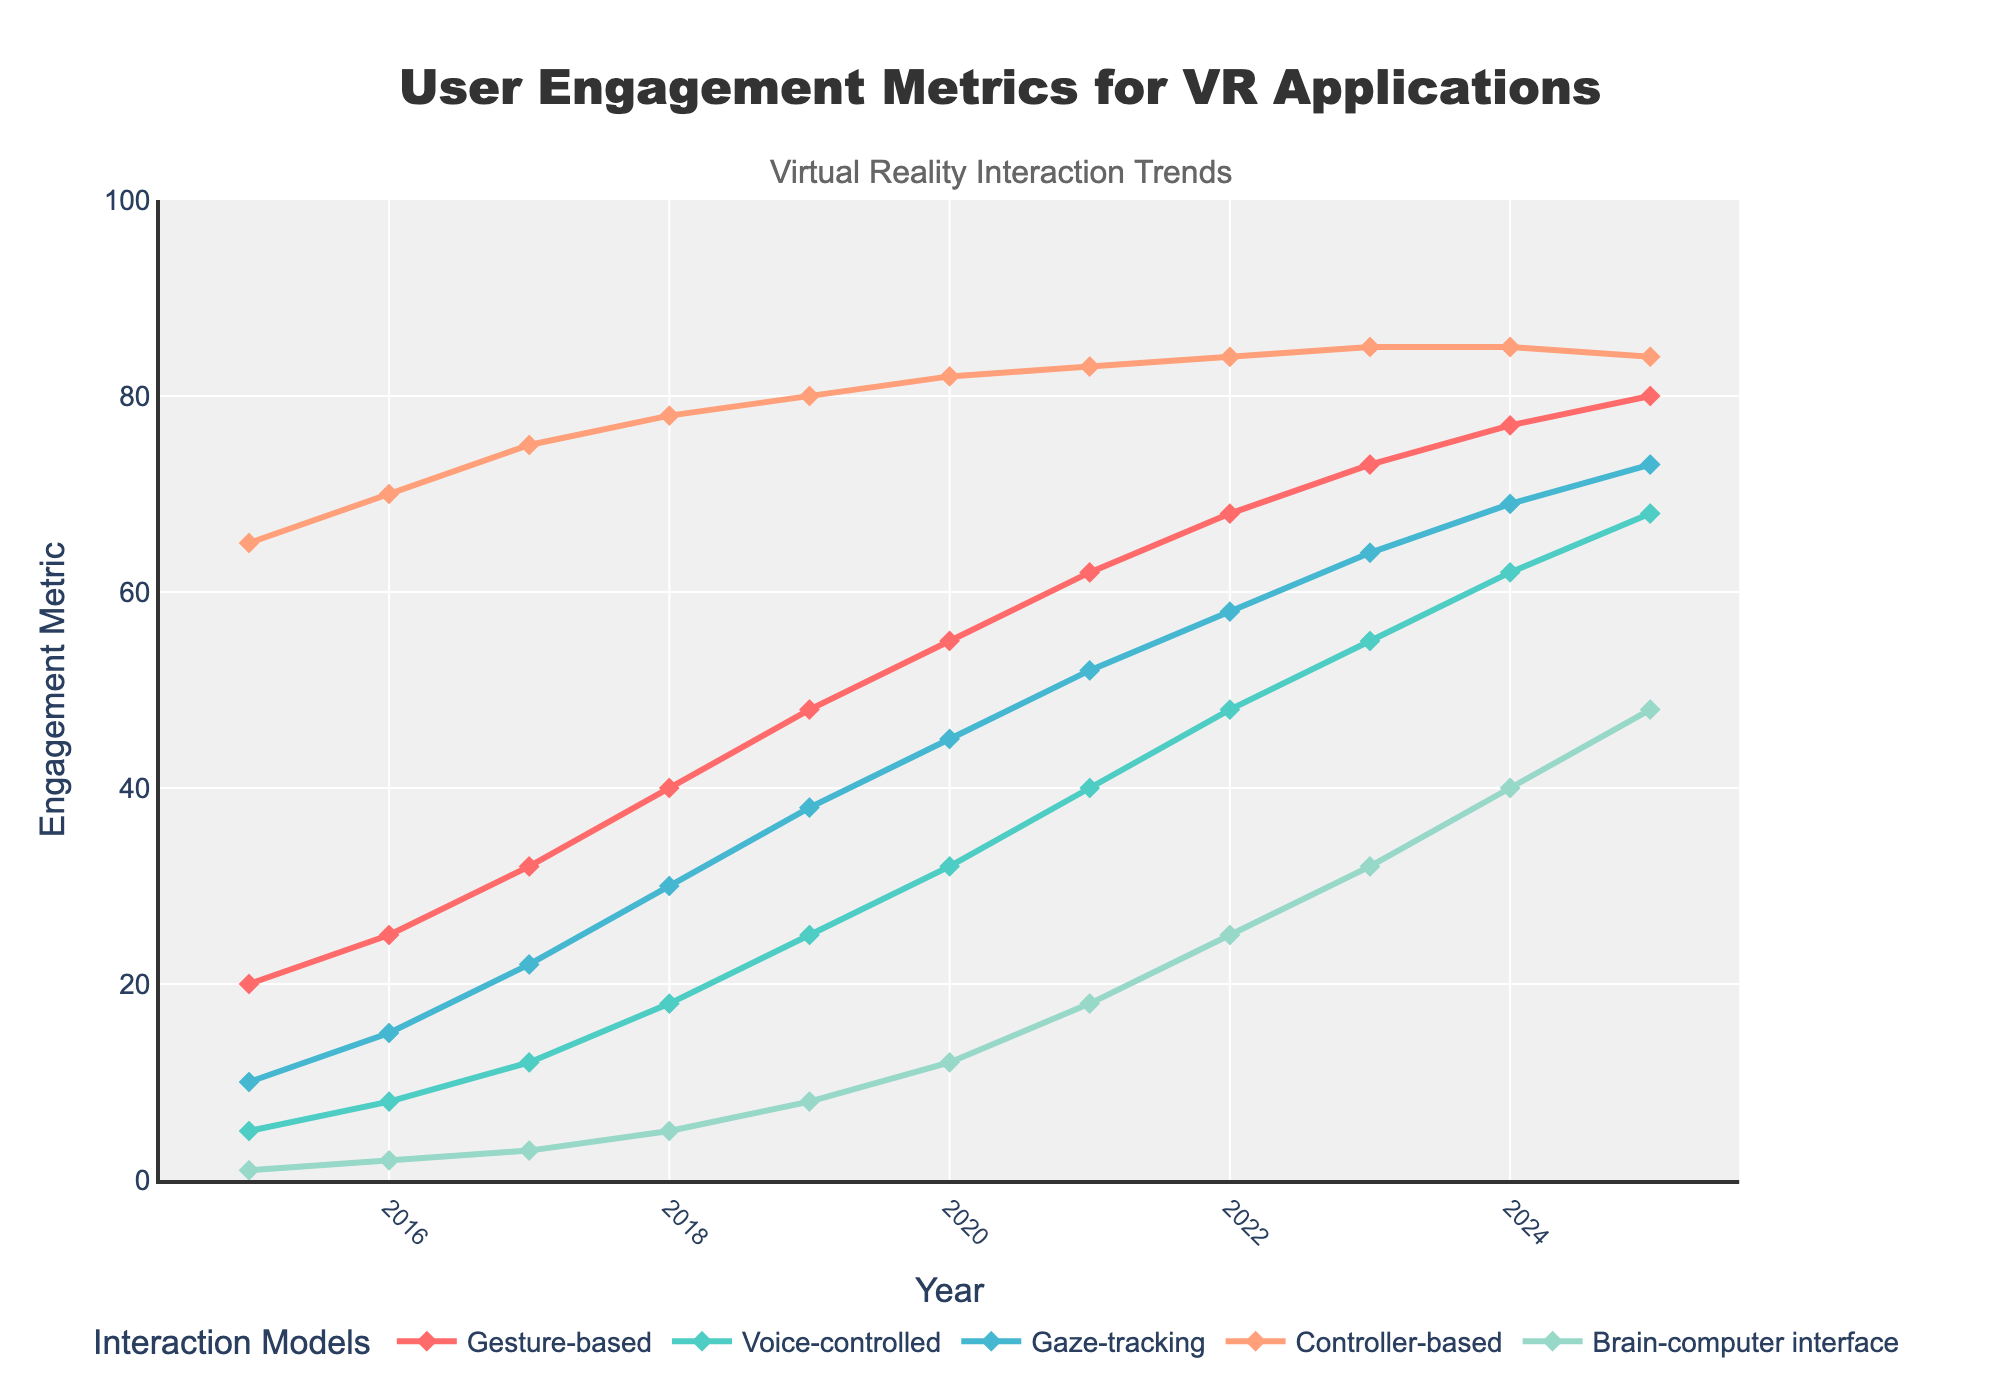What's the general trend for gesture-based interaction from 2015 to 2025? Observing the line representing gesture-based interaction, it consistently rises from 20 in 2015 to 80 in 2025, indicating a steady increase in user engagement over the years.
Answer: Steady increase Which interaction model had the highest engagement in 2025? Examining the endpoints of each line at the year 2025, the controller-based interaction has the highest engagement, peaking at 84.
Answer: Controller-based Between which years did the brain-computer interface see the most significant increase in engagement? Comparing the differences year over year, the biggest jump for the brain-computer interface is from 2024 to 2025, rising from 40 to 48 (an increase of 8).
Answer: 2024-2025 How does the engagement of voice-controlled interaction in 2023 compare to gesture-based interaction in 2015? The engagement for voice-controlled in 2023 is 55, whereas for gesture-based in 2015 it was 20 – indicating that voice-controlled in 2023 had considerably higher engagement.
Answer: Higher in 2023 What's the average engagement of gaze-tracking from 2015 to 2025? Sum the engagement values for gaze-tracking from 2015 to 2025 (10 + 15 + 22 + 30 + 38 + 45 + 52 + 58 + 64 + 69 + 73 = 476), then divide by the number of years (476 / 11 = 43.27).
Answer: 43.27 Which interaction model had the least engagement growth over the given period? Calculating the differences for each interaction model between 2015 and 2025: Gesture-based (80-20 = 60), Voice-controlled (68-5 = 63), Gaze-tracking (73-10 = 63), Controller-based (84-65 = 19), Brain-computer interface (48-1 = 47). The controller-based model had the smallest increase (19).
Answer: Controller-based What color represents the voice-controlled interaction, and how does its trend appear? The voice-controlled interaction is represented by a cyan line (4th color), and it shows a gradual increase from 5 in 2015 to 68 in 2025.
Answer: Cyan, gradual increase Comparing the years 2018 and 2025, by how much did user engagement for voice-controlled interaction increase? Subtracting the engagement values for voice-controlled in 2018 from that in 2025 (68 - 18 = 50).
Answer: 50 What is the relative difference in engagement between gesture-based and brain-computer interface models in 2020? The engagement for gesture-based in 2020 is 55 and for brain-computer interface is 12. The difference is 55 - 12 = 43.
Answer: 43 